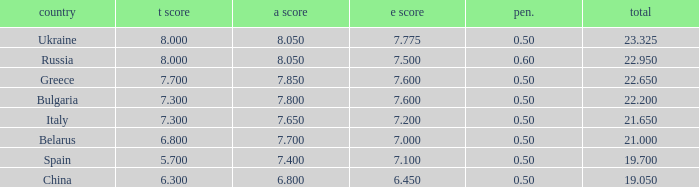What E score has the T score of 8 and a number smaller than 22.95? None. 